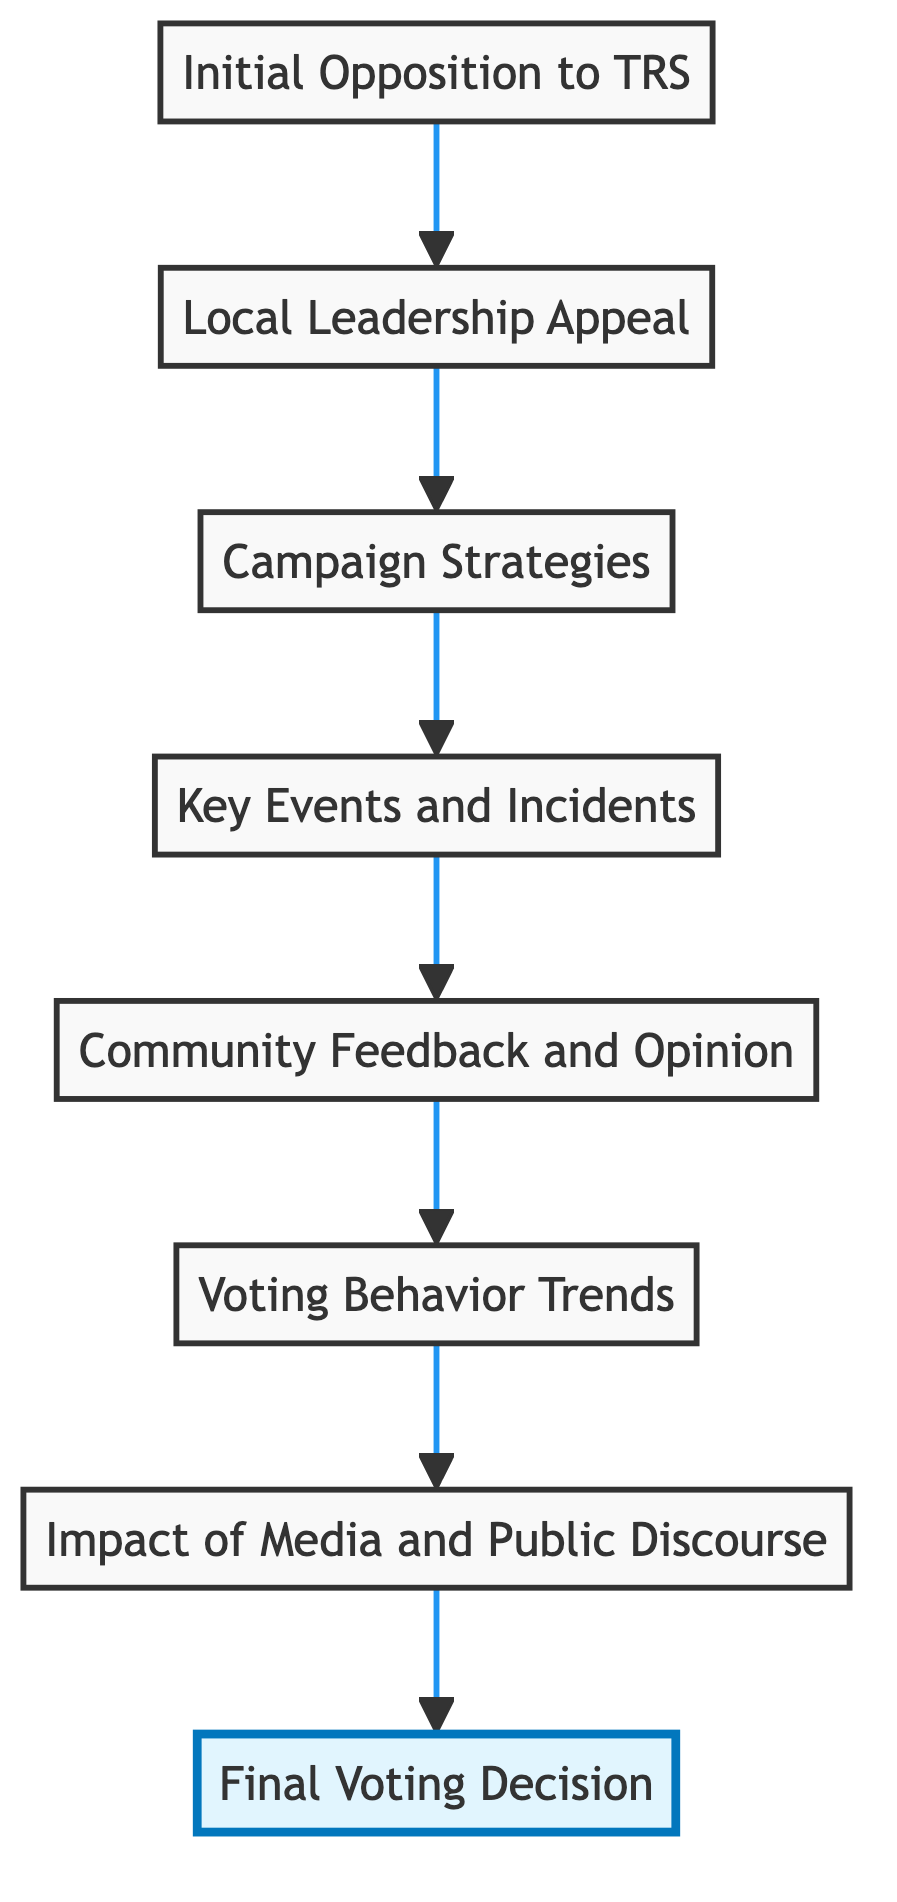What is the final outcome in the flow chart? The final node in the flow chart is "Final Voting Decision," indicating the ultimate result of the transformation.
Answer: Final Voting Decision Which node immediately precedes "Key Events and Incidents"? "Campaign Strategies" is the node that directly connects to "Key Events and Incidents," as per the directional flow of the diagram.
Answer: Campaign Strategies How many elements are represented in the diagram? There are eight elements displayed in the flow chart, as can be counted from the node labels.
Answer: Eight What is the main factor leading to "Voting Behavior Trends"? The preceding node "Community Feedback and Opinion" is the primary factor that leads to understanding the voting behavior trends in the constituency.
Answer: Community Feedback and Opinion Which node includes "water scarcity" as a concern? "Campaign Strategies" discusses local issues such as water scarcity, contributing to shaping voter sentiments against TRS.
Answer: Campaign Strategies What role do "Local Leadership Appeal" play in voter sentiment? "Local Leadership Appeal" serves as a pivotal influence in garnering support against TRS by appealing to the electorate through local candidates.
Answer: Pivotal influence How does "Impact of Media and Public Discourse" relate to "Final Voting Decision"? The "Impact of Media and Public Discourse" affects perceptions and sentiments that ultimately influence the "Final Voting Decision." Thus, it feeds into the decision-making process.
Answer: Influences decision-making What types of strategies are included in the "Campaign Strategies" node? The "Campaign Strategies" node includes targeted community meetings and social media outreach among others.
Answer: Targeted strategies 